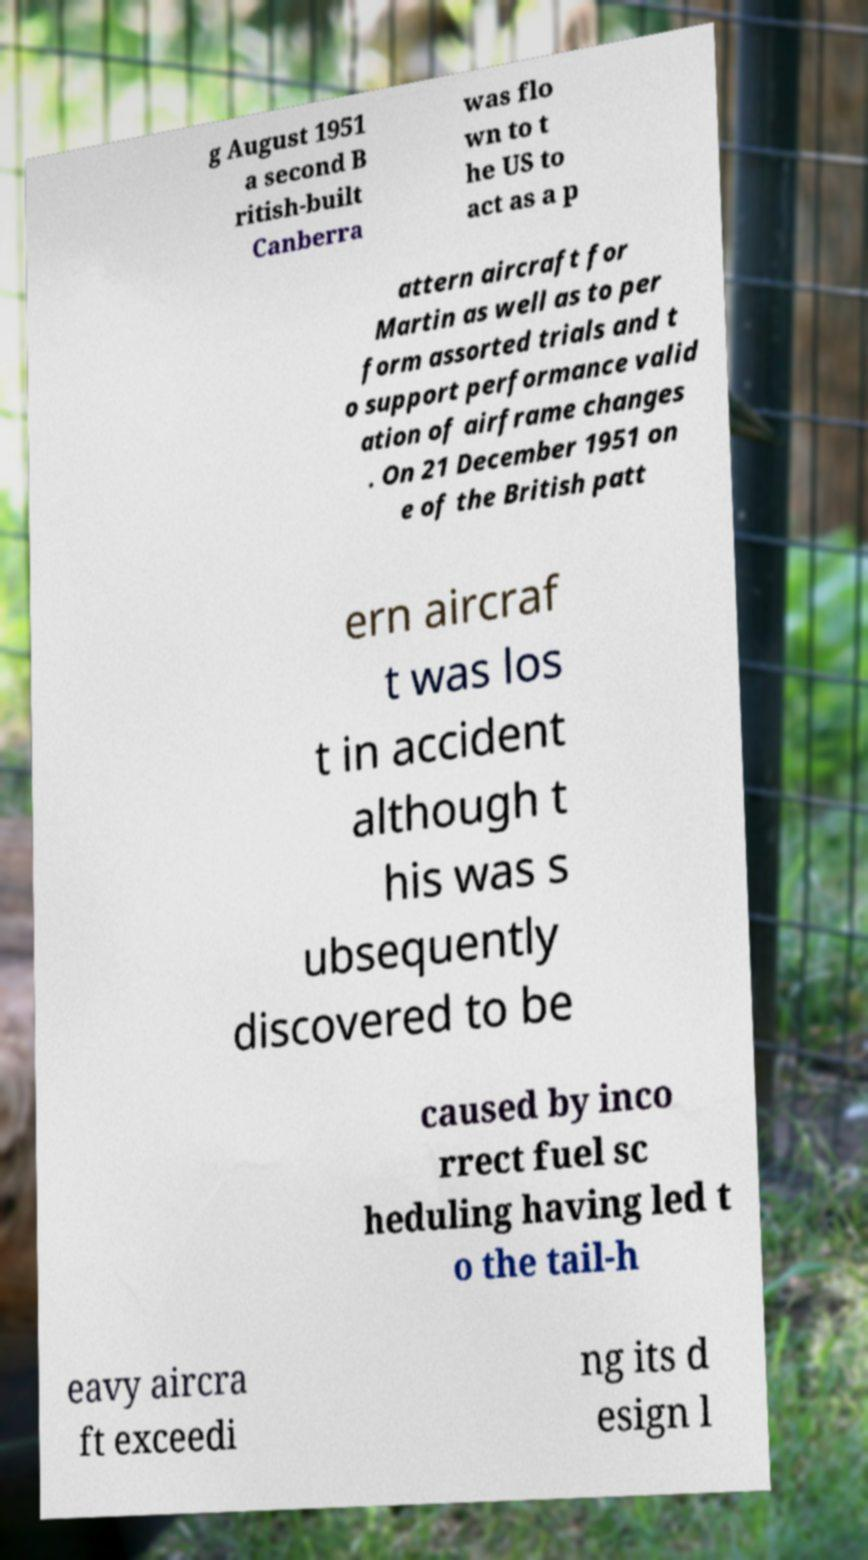Can you read and provide the text displayed in the image?This photo seems to have some interesting text. Can you extract and type it out for me? g August 1951 a second B ritish-built Canberra was flo wn to t he US to act as a p attern aircraft for Martin as well as to per form assorted trials and t o support performance valid ation of airframe changes . On 21 December 1951 on e of the British patt ern aircraf t was los t in accident although t his was s ubsequently discovered to be caused by inco rrect fuel sc heduling having led t o the tail-h eavy aircra ft exceedi ng its d esign l 